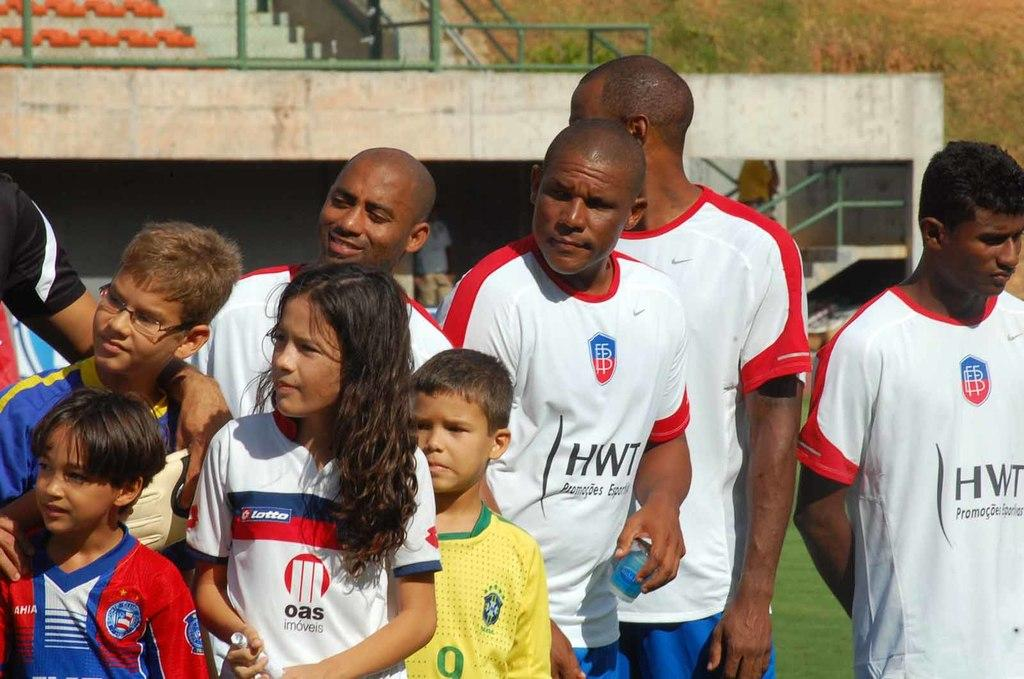Provide a one-sentence caption for the provided image. Soccer players wearing HWT jerseys are standing next to children wearing different soccer jerseys. 